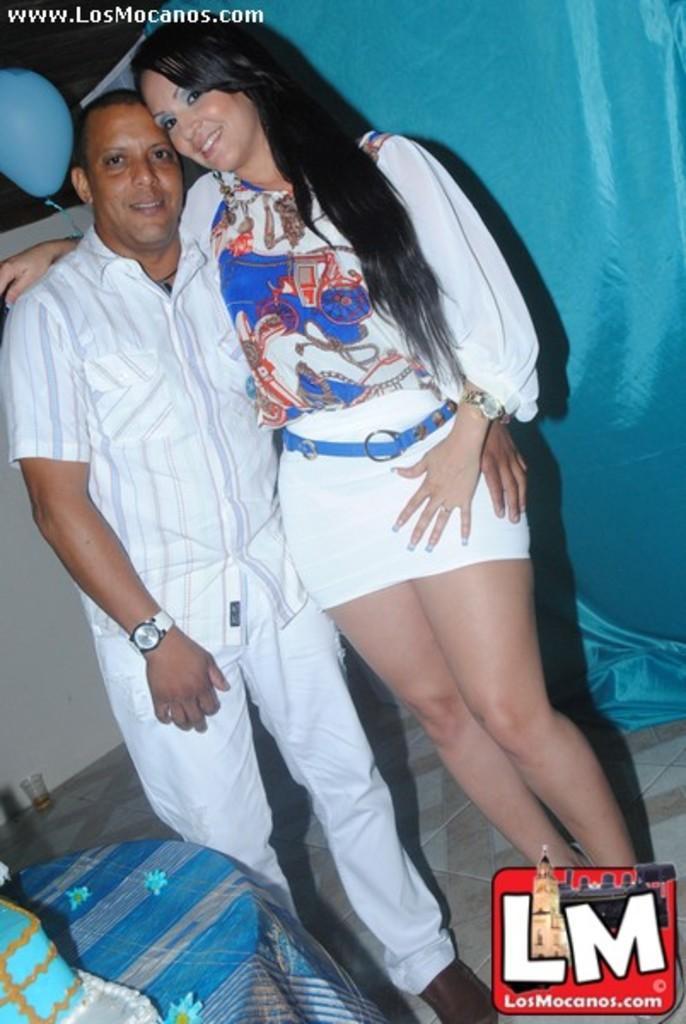Describe this image in one or two sentences. In this image I can see two people are standing and wearing white and blue color dresses. I can see the blue color cloth, glass, balloon and the white color wall. In front I can see the cake on the table. 